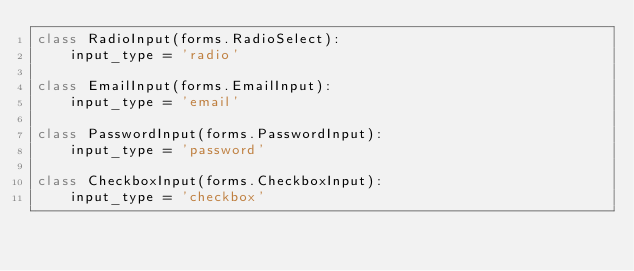Convert code to text. <code><loc_0><loc_0><loc_500><loc_500><_Python_>class RadioInput(forms.RadioSelect):
    input_type = 'radio'

class EmailInput(forms.EmailInput):
    input_type = 'email'

class PasswordInput(forms.PasswordInput):
    input_type = 'password'

class CheckboxInput(forms.CheckboxInput):
    input_type = 'checkbox'</code> 